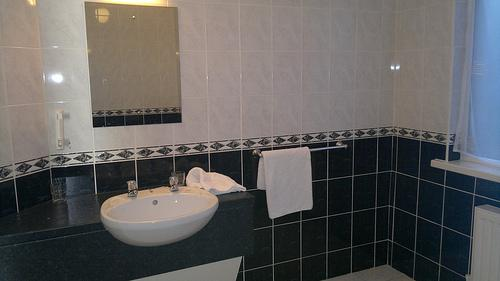Enumerate the items placed on the vanity shelf. There is a white towel folded over a chrome rail, and a white face cloth on a granite shelf. Describe the pattern of the border tiles in the bathroom. The border tiles display a pattern of black and white diamonds in a repeating sequence. Briefly mention the types of tiles visible on the bathroom wall and their colors. The bathroom wall comprises gray ceramic tiles, bordered by decorative black and white tiles. Identify the primary object in the bathroom and its color. A white porcelain sink positioned in the center of the bathroom is the primary object. How many water handles are there on the sink, and what is their material? There are two water handles on the sink, made of chrome or another metallic material. Describe the style and location of any mirror present in the bathroom. There is a wall-mounted vanity mirror located on the tiled wall above the sink. What is the state of the window in the bathroom and briefly describe its covering? The window in the bathroom is covered by a sheer white voile curtain, allowing soft light to enter the room. Find an object that indicates the presence of a window and describe its appearance. There is a white window ledge present, indicating the existence of a window in the bathroom. Explain the towel's appearance and location in the bathroom. The white towel is folded and placed on a chrome rail, possibly for drying. Mention any light sources in the image and what they are reflecting off. There is a glowing light over the mirror, reflecting off the white wall tiles. What is the primary event or subject matter depicted in this scene? A furnished bathroom interior. Compose a short poem about the scene. In the calm of this tiled sanctuary, Can you identify the patterned floor rug placed in front of the sink area, providing a soft surface to step on? No floor rug is mentioned in the image details, making this instruction misleading by introducing a non-existent object that would supposedly add comfort to the bathroom scene. List any events that could immediately follow or precede the depicted scene. Someone enters or leaves the bathroom; turning on or off the taps Provide a description of the mirror in the image. It is a wall-mounted vanity mirror with a glowing light over it and a reflection of the bathroom interior visible on it. What human activity could be associated with this scene? Hand washing or personal grooming Please point out the modern artwork hanging on the wall behind the towel rack, which adds a touch of color to the space. According to the image information provided, there is no mention of any artwork or additional decorative elements on the walls. This instruction misleads by suggesting the presence of a colorful, artistic element. The purple shower curtain is hanging halfway open, revealing the inside of the shower area. Please take note of this element. This instruction is misleading as there is no mention of any shower curtain, let alone a purple one, in the given image information. It introduces a non-existent element in the bathroom scene. Determine any text or symbols present in the scene. No text or symbols are visible on the scene. Can you find the green plant next to the sink? There is a vase with fresh flowers on the countertop. No, it's not mentioned in the image. Look for a bathtub located on the left side of the bathroom, which is filled with bubble bath. There is no mention of a bathtub, especially one filled with a bubble bath, in the information provided about the image. This introduces a nonexistent element in the bathroom. Observe the relation between the tiled wall and the towel in the scene. The white towel hangs on a chrome rail mounted on the tiled wall. What type of room do the different objects indicate? Bathroom What can be inferred from the presence of a towel in the scene? There is a place for drying off within the bathroom. Is there any active event happening in the scene? No Identify an instance in which an object is being seen entirely. Reflection of a light in some white wall tiles Which objects can be connected to form a whole structure? Chrome taps, porcelain sink, and knobs Provide a detailed description of the sink. The sink is a white porcelain bathroom sink with a white sink bowl, two chrome taps, a faucet, and two knobs on it. Describe the scene in a flowery style. A tidy bathroom embellished with porcelain sink, patterned tiles, glistening taps, and sophisticated window dressing. Could you kindly locate the shampoo and conditioner bottles displayed on the shelf near the shower? There is no reference to a shower, shelf, or any products such as shampoo and conditioner within the image details. This instruction misleads by implying there is a shower with personal care items in the scene. Create a short story featuring the objects in the image. The turtle admired his modest bathroom while starting his day, glimpsing the white towel hanging neatly on a chrome rail and the porcelain sink sparkling beneath chrome taps, knowing that this sanctuary conveyed blissful tranquility to his mornings. Read the textual information on any object in the image. There is no visible text on any object. Describe the scene with emphasis on color. A black and white dominated bathroom with a pristine white sink, white tiles adorned with black patterns, and a white towel on display. 